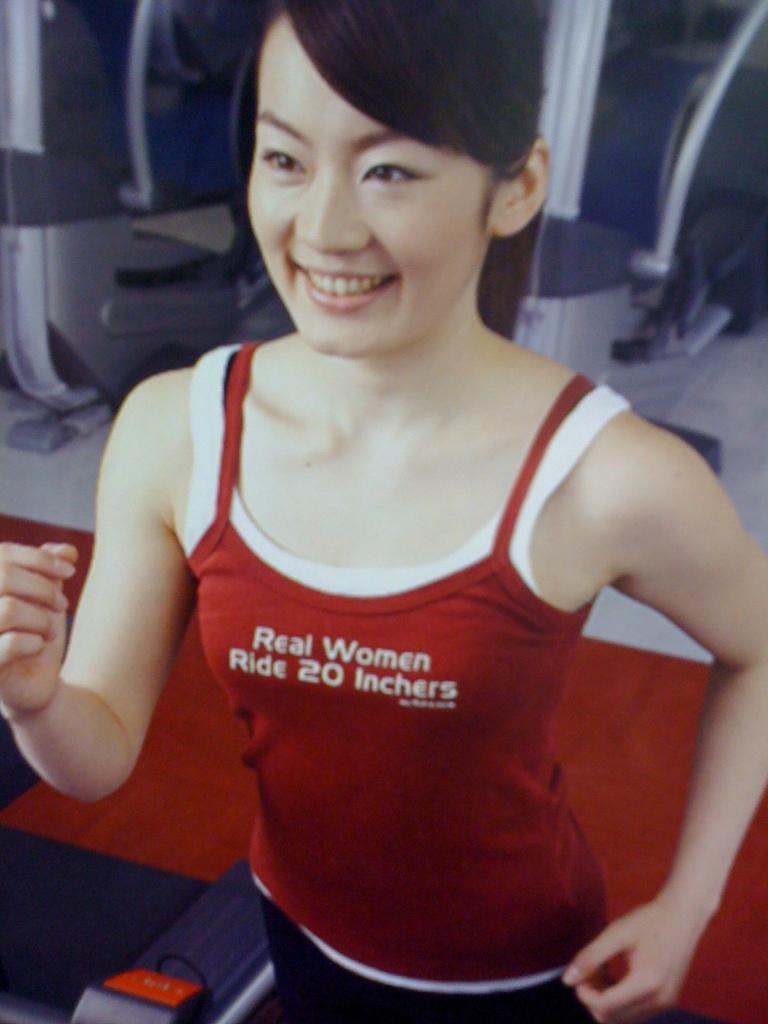Real women ride what?
Make the answer very short. 20 inchers. What do real women do?
Ensure brevity in your answer.  Ride 20 inchers. 